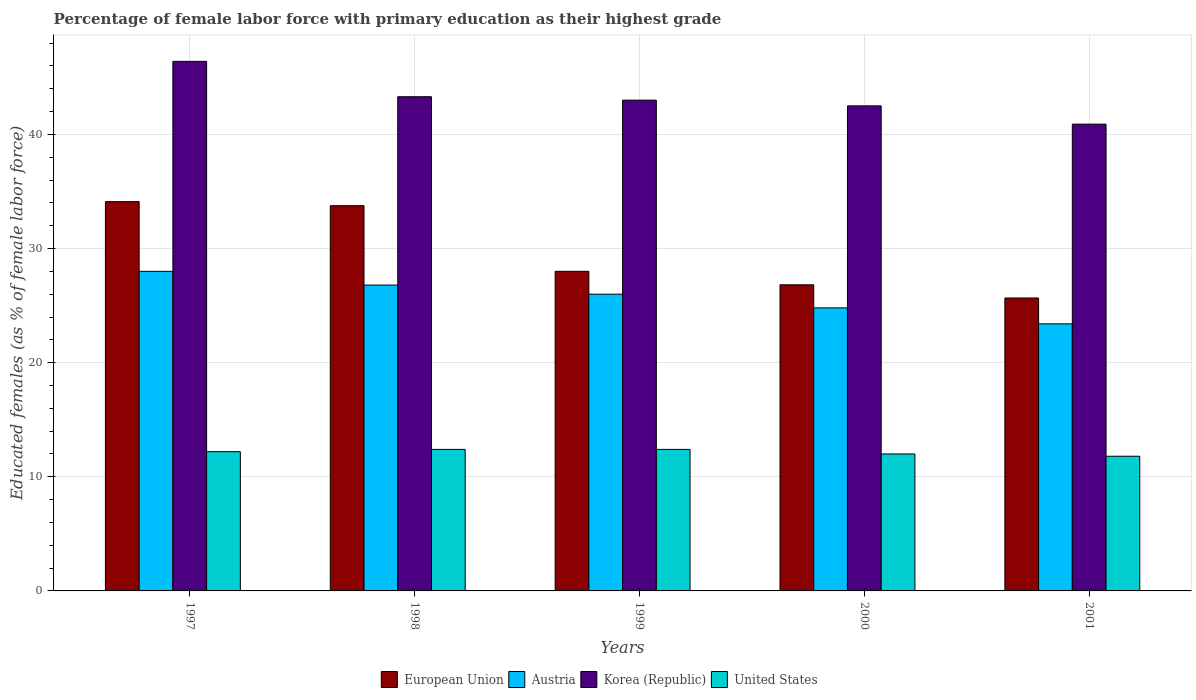How many groups of bars are there?
Provide a short and direct response. 5. Are the number of bars per tick equal to the number of legend labels?
Provide a succinct answer. Yes. How many bars are there on the 2nd tick from the left?
Offer a terse response. 4. How many bars are there on the 5th tick from the right?
Offer a very short reply. 4. What is the label of the 1st group of bars from the left?
Make the answer very short. 1997. What is the percentage of female labor force with primary education in United States in 1997?
Keep it short and to the point. 12.2. Across all years, what is the maximum percentage of female labor force with primary education in Korea (Republic)?
Your answer should be very brief. 46.4. Across all years, what is the minimum percentage of female labor force with primary education in European Union?
Make the answer very short. 25.67. What is the total percentage of female labor force with primary education in European Union in the graph?
Offer a terse response. 148.35. What is the difference between the percentage of female labor force with primary education in European Union in 2000 and that in 2001?
Your answer should be very brief. 1.15. What is the difference between the percentage of female labor force with primary education in Korea (Republic) in 1997 and the percentage of female labor force with primary education in United States in 2001?
Provide a short and direct response. 34.6. What is the average percentage of female labor force with primary education in Austria per year?
Provide a succinct answer. 25.8. In the year 2001, what is the difference between the percentage of female labor force with primary education in Korea (Republic) and percentage of female labor force with primary education in European Union?
Your response must be concise. 15.23. In how many years, is the percentage of female labor force with primary education in United States greater than 10 %?
Offer a very short reply. 5. What is the ratio of the percentage of female labor force with primary education in Austria in 2000 to that in 2001?
Offer a terse response. 1.06. What is the difference between the highest and the second highest percentage of female labor force with primary education in Korea (Republic)?
Offer a terse response. 3.1. What is the difference between the highest and the lowest percentage of female labor force with primary education in Austria?
Provide a short and direct response. 4.6. In how many years, is the percentage of female labor force with primary education in Korea (Republic) greater than the average percentage of female labor force with primary education in Korea (Republic) taken over all years?
Give a very brief answer. 2. Is the sum of the percentage of female labor force with primary education in European Union in 1997 and 2001 greater than the maximum percentage of female labor force with primary education in Austria across all years?
Ensure brevity in your answer.  Yes. What does the 3rd bar from the right in 1997 represents?
Your answer should be compact. Austria. How many bars are there?
Make the answer very short. 20. Are all the bars in the graph horizontal?
Provide a succinct answer. No. How many years are there in the graph?
Ensure brevity in your answer.  5. What is the difference between two consecutive major ticks on the Y-axis?
Your answer should be very brief. 10. How many legend labels are there?
Your answer should be very brief. 4. What is the title of the graph?
Your answer should be compact. Percentage of female labor force with primary education as their highest grade. Does "American Samoa" appear as one of the legend labels in the graph?
Offer a terse response. No. What is the label or title of the Y-axis?
Provide a succinct answer. Educated females (as % of female labor force). What is the Educated females (as % of female labor force) in European Union in 1997?
Offer a terse response. 34.11. What is the Educated females (as % of female labor force) in Korea (Republic) in 1997?
Ensure brevity in your answer.  46.4. What is the Educated females (as % of female labor force) in United States in 1997?
Make the answer very short. 12.2. What is the Educated females (as % of female labor force) of European Union in 1998?
Make the answer very short. 33.75. What is the Educated females (as % of female labor force) of Austria in 1998?
Your answer should be compact. 26.8. What is the Educated females (as % of female labor force) of Korea (Republic) in 1998?
Provide a short and direct response. 43.3. What is the Educated females (as % of female labor force) in United States in 1998?
Provide a succinct answer. 12.4. What is the Educated females (as % of female labor force) of European Union in 1999?
Make the answer very short. 28. What is the Educated females (as % of female labor force) of Austria in 1999?
Give a very brief answer. 26. What is the Educated females (as % of female labor force) of Korea (Republic) in 1999?
Keep it short and to the point. 43. What is the Educated females (as % of female labor force) in United States in 1999?
Give a very brief answer. 12.4. What is the Educated females (as % of female labor force) of European Union in 2000?
Your answer should be compact. 26.82. What is the Educated females (as % of female labor force) in Austria in 2000?
Your answer should be compact. 24.8. What is the Educated females (as % of female labor force) in Korea (Republic) in 2000?
Keep it short and to the point. 42.5. What is the Educated females (as % of female labor force) in United States in 2000?
Your response must be concise. 12. What is the Educated females (as % of female labor force) of European Union in 2001?
Ensure brevity in your answer.  25.67. What is the Educated females (as % of female labor force) in Austria in 2001?
Provide a short and direct response. 23.4. What is the Educated females (as % of female labor force) in Korea (Republic) in 2001?
Keep it short and to the point. 40.9. What is the Educated females (as % of female labor force) in United States in 2001?
Keep it short and to the point. 11.8. Across all years, what is the maximum Educated females (as % of female labor force) of European Union?
Provide a short and direct response. 34.11. Across all years, what is the maximum Educated females (as % of female labor force) of Korea (Republic)?
Keep it short and to the point. 46.4. Across all years, what is the maximum Educated females (as % of female labor force) of United States?
Your response must be concise. 12.4. Across all years, what is the minimum Educated females (as % of female labor force) of European Union?
Make the answer very short. 25.67. Across all years, what is the minimum Educated females (as % of female labor force) of Austria?
Make the answer very short. 23.4. Across all years, what is the minimum Educated females (as % of female labor force) in Korea (Republic)?
Your answer should be compact. 40.9. Across all years, what is the minimum Educated females (as % of female labor force) of United States?
Give a very brief answer. 11.8. What is the total Educated females (as % of female labor force) in European Union in the graph?
Keep it short and to the point. 148.35. What is the total Educated females (as % of female labor force) of Austria in the graph?
Your answer should be compact. 129. What is the total Educated females (as % of female labor force) in Korea (Republic) in the graph?
Offer a terse response. 216.1. What is the total Educated females (as % of female labor force) of United States in the graph?
Offer a very short reply. 60.8. What is the difference between the Educated females (as % of female labor force) of European Union in 1997 and that in 1998?
Make the answer very short. 0.36. What is the difference between the Educated females (as % of female labor force) in Austria in 1997 and that in 1998?
Ensure brevity in your answer.  1.2. What is the difference between the Educated females (as % of female labor force) of Korea (Republic) in 1997 and that in 1998?
Offer a very short reply. 3.1. What is the difference between the Educated females (as % of female labor force) in United States in 1997 and that in 1998?
Your answer should be very brief. -0.2. What is the difference between the Educated females (as % of female labor force) in European Union in 1997 and that in 1999?
Ensure brevity in your answer.  6.11. What is the difference between the Educated females (as % of female labor force) of Austria in 1997 and that in 1999?
Keep it short and to the point. 2. What is the difference between the Educated females (as % of female labor force) of European Union in 1997 and that in 2000?
Your answer should be compact. 7.29. What is the difference between the Educated females (as % of female labor force) in Austria in 1997 and that in 2000?
Provide a short and direct response. 3.2. What is the difference between the Educated females (as % of female labor force) in United States in 1997 and that in 2000?
Your answer should be compact. 0.2. What is the difference between the Educated females (as % of female labor force) in European Union in 1997 and that in 2001?
Your answer should be very brief. 8.44. What is the difference between the Educated females (as % of female labor force) in Austria in 1997 and that in 2001?
Ensure brevity in your answer.  4.6. What is the difference between the Educated females (as % of female labor force) in United States in 1997 and that in 2001?
Offer a very short reply. 0.4. What is the difference between the Educated females (as % of female labor force) of European Union in 1998 and that in 1999?
Your response must be concise. 5.75. What is the difference between the Educated females (as % of female labor force) of Austria in 1998 and that in 1999?
Offer a terse response. 0.8. What is the difference between the Educated females (as % of female labor force) of European Union in 1998 and that in 2000?
Ensure brevity in your answer.  6.93. What is the difference between the Educated females (as % of female labor force) in Korea (Republic) in 1998 and that in 2000?
Your response must be concise. 0.8. What is the difference between the Educated females (as % of female labor force) in European Union in 1998 and that in 2001?
Keep it short and to the point. 8.08. What is the difference between the Educated females (as % of female labor force) of Austria in 1998 and that in 2001?
Your answer should be very brief. 3.4. What is the difference between the Educated females (as % of female labor force) of Korea (Republic) in 1998 and that in 2001?
Your response must be concise. 2.4. What is the difference between the Educated females (as % of female labor force) in European Union in 1999 and that in 2000?
Give a very brief answer. 1.18. What is the difference between the Educated females (as % of female labor force) of Austria in 1999 and that in 2000?
Provide a succinct answer. 1.2. What is the difference between the Educated females (as % of female labor force) in Korea (Republic) in 1999 and that in 2000?
Provide a short and direct response. 0.5. What is the difference between the Educated females (as % of female labor force) in United States in 1999 and that in 2000?
Make the answer very short. 0.4. What is the difference between the Educated females (as % of female labor force) in European Union in 1999 and that in 2001?
Provide a succinct answer. 2.33. What is the difference between the Educated females (as % of female labor force) in Korea (Republic) in 1999 and that in 2001?
Your answer should be very brief. 2.1. What is the difference between the Educated females (as % of female labor force) in United States in 1999 and that in 2001?
Your answer should be compact. 0.6. What is the difference between the Educated females (as % of female labor force) of European Union in 2000 and that in 2001?
Your response must be concise. 1.15. What is the difference between the Educated females (as % of female labor force) of European Union in 1997 and the Educated females (as % of female labor force) of Austria in 1998?
Your response must be concise. 7.31. What is the difference between the Educated females (as % of female labor force) in European Union in 1997 and the Educated females (as % of female labor force) in Korea (Republic) in 1998?
Provide a short and direct response. -9.19. What is the difference between the Educated females (as % of female labor force) of European Union in 1997 and the Educated females (as % of female labor force) of United States in 1998?
Your answer should be very brief. 21.71. What is the difference between the Educated females (as % of female labor force) of Austria in 1997 and the Educated females (as % of female labor force) of Korea (Republic) in 1998?
Provide a short and direct response. -15.3. What is the difference between the Educated females (as % of female labor force) in Korea (Republic) in 1997 and the Educated females (as % of female labor force) in United States in 1998?
Your answer should be compact. 34. What is the difference between the Educated females (as % of female labor force) of European Union in 1997 and the Educated females (as % of female labor force) of Austria in 1999?
Keep it short and to the point. 8.11. What is the difference between the Educated females (as % of female labor force) of European Union in 1997 and the Educated females (as % of female labor force) of Korea (Republic) in 1999?
Keep it short and to the point. -8.89. What is the difference between the Educated females (as % of female labor force) in European Union in 1997 and the Educated females (as % of female labor force) in United States in 1999?
Offer a terse response. 21.71. What is the difference between the Educated females (as % of female labor force) of Austria in 1997 and the Educated females (as % of female labor force) of Korea (Republic) in 1999?
Your response must be concise. -15. What is the difference between the Educated females (as % of female labor force) of Austria in 1997 and the Educated females (as % of female labor force) of United States in 1999?
Your answer should be very brief. 15.6. What is the difference between the Educated females (as % of female labor force) of Korea (Republic) in 1997 and the Educated females (as % of female labor force) of United States in 1999?
Offer a terse response. 34. What is the difference between the Educated females (as % of female labor force) of European Union in 1997 and the Educated females (as % of female labor force) of Austria in 2000?
Offer a very short reply. 9.31. What is the difference between the Educated females (as % of female labor force) in European Union in 1997 and the Educated females (as % of female labor force) in Korea (Republic) in 2000?
Your answer should be very brief. -8.39. What is the difference between the Educated females (as % of female labor force) in European Union in 1997 and the Educated females (as % of female labor force) in United States in 2000?
Keep it short and to the point. 22.11. What is the difference between the Educated females (as % of female labor force) in Austria in 1997 and the Educated females (as % of female labor force) in Korea (Republic) in 2000?
Keep it short and to the point. -14.5. What is the difference between the Educated females (as % of female labor force) in Korea (Republic) in 1997 and the Educated females (as % of female labor force) in United States in 2000?
Make the answer very short. 34.4. What is the difference between the Educated females (as % of female labor force) of European Union in 1997 and the Educated females (as % of female labor force) of Austria in 2001?
Ensure brevity in your answer.  10.71. What is the difference between the Educated females (as % of female labor force) of European Union in 1997 and the Educated females (as % of female labor force) of Korea (Republic) in 2001?
Your answer should be very brief. -6.79. What is the difference between the Educated females (as % of female labor force) of European Union in 1997 and the Educated females (as % of female labor force) of United States in 2001?
Keep it short and to the point. 22.31. What is the difference between the Educated females (as % of female labor force) of Korea (Republic) in 1997 and the Educated females (as % of female labor force) of United States in 2001?
Ensure brevity in your answer.  34.6. What is the difference between the Educated females (as % of female labor force) in European Union in 1998 and the Educated females (as % of female labor force) in Austria in 1999?
Give a very brief answer. 7.75. What is the difference between the Educated females (as % of female labor force) of European Union in 1998 and the Educated females (as % of female labor force) of Korea (Republic) in 1999?
Keep it short and to the point. -9.25. What is the difference between the Educated females (as % of female labor force) in European Union in 1998 and the Educated females (as % of female labor force) in United States in 1999?
Your response must be concise. 21.35. What is the difference between the Educated females (as % of female labor force) of Austria in 1998 and the Educated females (as % of female labor force) of Korea (Republic) in 1999?
Give a very brief answer. -16.2. What is the difference between the Educated females (as % of female labor force) in Korea (Republic) in 1998 and the Educated females (as % of female labor force) in United States in 1999?
Provide a succinct answer. 30.9. What is the difference between the Educated females (as % of female labor force) of European Union in 1998 and the Educated females (as % of female labor force) of Austria in 2000?
Your answer should be very brief. 8.95. What is the difference between the Educated females (as % of female labor force) of European Union in 1998 and the Educated females (as % of female labor force) of Korea (Republic) in 2000?
Your answer should be very brief. -8.75. What is the difference between the Educated females (as % of female labor force) in European Union in 1998 and the Educated females (as % of female labor force) in United States in 2000?
Give a very brief answer. 21.75. What is the difference between the Educated females (as % of female labor force) of Austria in 1998 and the Educated females (as % of female labor force) of Korea (Republic) in 2000?
Give a very brief answer. -15.7. What is the difference between the Educated females (as % of female labor force) of Austria in 1998 and the Educated females (as % of female labor force) of United States in 2000?
Your response must be concise. 14.8. What is the difference between the Educated females (as % of female labor force) in Korea (Republic) in 1998 and the Educated females (as % of female labor force) in United States in 2000?
Provide a succinct answer. 31.3. What is the difference between the Educated females (as % of female labor force) of European Union in 1998 and the Educated females (as % of female labor force) of Austria in 2001?
Offer a terse response. 10.35. What is the difference between the Educated females (as % of female labor force) in European Union in 1998 and the Educated females (as % of female labor force) in Korea (Republic) in 2001?
Provide a succinct answer. -7.15. What is the difference between the Educated females (as % of female labor force) in European Union in 1998 and the Educated females (as % of female labor force) in United States in 2001?
Your response must be concise. 21.95. What is the difference between the Educated females (as % of female labor force) of Austria in 1998 and the Educated females (as % of female labor force) of Korea (Republic) in 2001?
Offer a terse response. -14.1. What is the difference between the Educated females (as % of female labor force) in Austria in 1998 and the Educated females (as % of female labor force) in United States in 2001?
Offer a very short reply. 15. What is the difference between the Educated females (as % of female labor force) of Korea (Republic) in 1998 and the Educated females (as % of female labor force) of United States in 2001?
Keep it short and to the point. 31.5. What is the difference between the Educated females (as % of female labor force) in European Union in 1999 and the Educated females (as % of female labor force) in Austria in 2000?
Offer a very short reply. 3.2. What is the difference between the Educated females (as % of female labor force) of European Union in 1999 and the Educated females (as % of female labor force) of Korea (Republic) in 2000?
Your answer should be very brief. -14.5. What is the difference between the Educated females (as % of female labor force) of European Union in 1999 and the Educated females (as % of female labor force) of United States in 2000?
Offer a terse response. 16. What is the difference between the Educated females (as % of female labor force) in Austria in 1999 and the Educated females (as % of female labor force) in Korea (Republic) in 2000?
Give a very brief answer. -16.5. What is the difference between the Educated females (as % of female labor force) of Austria in 1999 and the Educated females (as % of female labor force) of United States in 2000?
Offer a terse response. 14. What is the difference between the Educated females (as % of female labor force) in European Union in 1999 and the Educated females (as % of female labor force) in Austria in 2001?
Provide a succinct answer. 4.6. What is the difference between the Educated females (as % of female labor force) in European Union in 1999 and the Educated females (as % of female labor force) in Korea (Republic) in 2001?
Make the answer very short. -12.9. What is the difference between the Educated females (as % of female labor force) of European Union in 1999 and the Educated females (as % of female labor force) of United States in 2001?
Your response must be concise. 16.2. What is the difference between the Educated females (as % of female labor force) of Austria in 1999 and the Educated females (as % of female labor force) of Korea (Republic) in 2001?
Your response must be concise. -14.9. What is the difference between the Educated females (as % of female labor force) in Korea (Republic) in 1999 and the Educated females (as % of female labor force) in United States in 2001?
Offer a terse response. 31.2. What is the difference between the Educated females (as % of female labor force) in European Union in 2000 and the Educated females (as % of female labor force) in Austria in 2001?
Give a very brief answer. 3.42. What is the difference between the Educated females (as % of female labor force) of European Union in 2000 and the Educated females (as % of female labor force) of Korea (Republic) in 2001?
Provide a succinct answer. -14.08. What is the difference between the Educated females (as % of female labor force) in European Union in 2000 and the Educated females (as % of female labor force) in United States in 2001?
Keep it short and to the point. 15.02. What is the difference between the Educated females (as % of female labor force) of Austria in 2000 and the Educated females (as % of female labor force) of Korea (Republic) in 2001?
Keep it short and to the point. -16.1. What is the difference between the Educated females (as % of female labor force) of Korea (Republic) in 2000 and the Educated females (as % of female labor force) of United States in 2001?
Provide a short and direct response. 30.7. What is the average Educated females (as % of female labor force) of European Union per year?
Offer a terse response. 29.67. What is the average Educated females (as % of female labor force) in Austria per year?
Offer a very short reply. 25.8. What is the average Educated females (as % of female labor force) in Korea (Republic) per year?
Offer a very short reply. 43.22. What is the average Educated females (as % of female labor force) of United States per year?
Offer a very short reply. 12.16. In the year 1997, what is the difference between the Educated females (as % of female labor force) in European Union and Educated females (as % of female labor force) in Austria?
Make the answer very short. 6.11. In the year 1997, what is the difference between the Educated females (as % of female labor force) of European Union and Educated females (as % of female labor force) of Korea (Republic)?
Keep it short and to the point. -12.29. In the year 1997, what is the difference between the Educated females (as % of female labor force) of European Union and Educated females (as % of female labor force) of United States?
Keep it short and to the point. 21.91. In the year 1997, what is the difference between the Educated females (as % of female labor force) in Austria and Educated females (as % of female labor force) in Korea (Republic)?
Your response must be concise. -18.4. In the year 1997, what is the difference between the Educated females (as % of female labor force) in Austria and Educated females (as % of female labor force) in United States?
Provide a succinct answer. 15.8. In the year 1997, what is the difference between the Educated females (as % of female labor force) of Korea (Republic) and Educated females (as % of female labor force) of United States?
Provide a short and direct response. 34.2. In the year 1998, what is the difference between the Educated females (as % of female labor force) of European Union and Educated females (as % of female labor force) of Austria?
Offer a terse response. 6.95. In the year 1998, what is the difference between the Educated females (as % of female labor force) in European Union and Educated females (as % of female labor force) in Korea (Republic)?
Keep it short and to the point. -9.55. In the year 1998, what is the difference between the Educated females (as % of female labor force) of European Union and Educated females (as % of female labor force) of United States?
Give a very brief answer. 21.35. In the year 1998, what is the difference between the Educated females (as % of female labor force) in Austria and Educated females (as % of female labor force) in Korea (Republic)?
Your answer should be compact. -16.5. In the year 1998, what is the difference between the Educated females (as % of female labor force) of Austria and Educated females (as % of female labor force) of United States?
Provide a succinct answer. 14.4. In the year 1998, what is the difference between the Educated females (as % of female labor force) in Korea (Republic) and Educated females (as % of female labor force) in United States?
Your response must be concise. 30.9. In the year 1999, what is the difference between the Educated females (as % of female labor force) in European Union and Educated females (as % of female labor force) in Austria?
Offer a terse response. 2. In the year 1999, what is the difference between the Educated females (as % of female labor force) in European Union and Educated females (as % of female labor force) in Korea (Republic)?
Give a very brief answer. -15. In the year 1999, what is the difference between the Educated females (as % of female labor force) in European Union and Educated females (as % of female labor force) in United States?
Provide a short and direct response. 15.6. In the year 1999, what is the difference between the Educated females (as % of female labor force) in Austria and Educated females (as % of female labor force) in United States?
Make the answer very short. 13.6. In the year 1999, what is the difference between the Educated females (as % of female labor force) in Korea (Republic) and Educated females (as % of female labor force) in United States?
Keep it short and to the point. 30.6. In the year 2000, what is the difference between the Educated females (as % of female labor force) of European Union and Educated females (as % of female labor force) of Austria?
Provide a short and direct response. 2.02. In the year 2000, what is the difference between the Educated females (as % of female labor force) in European Union and Educated females (as % of female labor force) in Korea (Republic)?
Give a very brief answer. -15.68. In the year 2000, what is the difference between the Educated females (as % of female labor force) in European Union and Educated females (as % of female labor force) in United States?
Offer a terse response. 14.82. In the year 2000, what is the difference between the Educated females (as % of female labor force) in Austria and Educated females (as % of female labor force) in Korea (Republic)?
Provide a succinct answer. -17.7. In the year 2000, what is the difference between the Educated females (as % of female labor force) of Austria and Educated females (as % of female labor force) of United States?
Offer a very short reply. 12.8. In the year 2000, what is the difference between the Educated females (as % of female labor force) in Korea (Republic) and Educated females (as % of female labor force) in United States?
Provide a succinct answer. 30.5. In the year 2001, what is the difference between the Educated females (as % of female labor force) of European Union and Educated females (as % of female labor force) of Austria?
Your response must be concise. 2.27. In the year 2001, what is the difference between the Educated females (as % of female labor force) in European Union and Educated females (as % of female labor force) in Korea (Republic)?
Your answer should be very brief. -15.23. In the year 2001, what is the difference between the Educated females (as % of female labor force) in European Union and Educated females (as % of female labor force) in United States?
Ensure brevity in your answer.  13.87. In the year 2001, what is the difference between the Educated females (as % of female labor force) of Austria and Educated females (as % of female labor force) of Korea (Republic)?
Your answer should be very brief. -17.5. In the year 2001, what is the difference between the Educated females (as % of female labor force) in Korea (Republic) and Educated females (as % of female labor force) in United States?
Your response must be concise. 29.1. What is the ratio of the Educated females (as % of female labor force) in European Union in 1997 to that in 1998?
Your answer should be compact. 1.01. What is the ratio of the Educated females (as % of female labor force) of Austria in 1997 to that in 1998?
Your response must be concise. 1.04. What is the ratio of the Educated females (as % of female labor force) in Korea (Republic) in 1997 to that in 1998?
Make the answer very short. 1.07. What is the ratio of the Educated females (as % of female labor force) in United States in 1997 to that in 1998?
Keep it short and to the point. 0.98. What is the ratio of the Educated females (as % of female labor force) of European Union in 1997 to that in 1999?
Keep it short and to the point. 1.22. What is the ratio of the Educated females (as % of female labor force) of Korea (Republic) in 1997 to that in 1999?
Keep it short and to the point. 1.08. What is the ratio of the Educated females (as % of female labor force) of United States in 1997 to that in 1999?
Ensure brevity in your answer.  0.98. What is the ratio of the Educated females (as % of female labor force) in European Union in 1997 to that in 2000?
Your answer should be compact. 1.27. What is the ratio of the Educated females (as % of female labor force) in Austria in 1997 to that in 2000?
Keep it short and to the point. 1.13. What is the ratio of the Educated females (as % of female labor force) in Korea (Republic) in 1997 to that in 2000?
Your answer should be very brief. 1.09. What is the ratio of the Educated females (as % of female labor force) in United States in 1997 to that in 2000?
Your response must be concise. 1.02. What is the ratio of the Educated females (as % of female labor force) of European Union in 1997 to that in 2001?
Your answer should be very brief. 1.33. What is the ratio of the Educated females (as % of female labor force) in Austria in 1997 to that in 2001?
Give a very brief answer. 1.2. What is the ratio of the Educated females (as % of female labor force) of Korea (Republic) in 1997 to that in 2001?
Ensure brevity in your answer.  1.13. What is the ratio of the Educated females (as % of female labor force) of United States in 1997 to that in 2001?
Keep it short and to the point. 1.03. What is the ratio of the Educated females (as % of female labor force) of European Union in 1998 to that in 1999?
Give a very brief answer. 1.21. What is the ratio of the Educated females (as % of female labor force) in Austria in 1998 to that in 1999?
Give a very brief answer. 1.03. What is the ratio of the Educated females (as % of female labor force) of European Union in 1998 to that in 2000?
Your answer should be compact. 1.26. What is the ratio of the Educated females (as % of female labor force) in Austria in 1998 to that in 2000?
Offer a terse response. 1.08. What is the ratio of the Educated females (as % of female labor force) in Korea (Republic) in 1998 to that in 2000?
Make the answer very short. 1.02. What is the ratio of the Educated females (as % of female labor force) in United States in 1998 to that in 2000?
Offer a terse response. 1.03. What is the ratio of the Educated females (as % of female labor force) in European Union in 1998 to that in 2001?
Ensure brevity in your answer.  1.31. What is the ratio of the Educated females (as % of female labor force) of Austria in 1998 to that in 2001?
Offer a terse response. 1.15. What is the ratio of the Educated females (as % of female labor force) in Korea (Republic) in 1998 to that in 2001?
Keep it short and to the point. 1.06. What is the ratio of the Educated females (as % of female labor force) of United States in 1998 to that in 2001?
Offer a very short reply. 1.05. What is the ratio of the Educated females (as % of female labor force) in European Union in 1999 to that in 2000?
Make the answer very short. 1.04. What is the ratio of the Educated females (as % of female labor force) in Austria in 1999 to that in 2000?
Your response must be concise. 1.05. What is the ratio of the Educated females (as % of female labor force) of Korea (Republic) in 1999 to that in 2000?
Make the answer very short. 1.01. What is the ratio of the Educated females (as % of female labor force) of United States in 1999 to that in 2000?
Offer a terse response. 1.03. What is the ratio of the Educated females (as % of female labor force) of European Union in 1999 to that in 2001?
Ensure brevity in your answer.  1.09. What is the ratio of the Educated females (as % of female labor force) in Korea (Republic) in 1999 to that in 2001?
Your answer should be very brief. 1.05. What is the ratio of the Educated females (as % of female labor force) of United States in 1999 to that in 2001?
Your answer should be very brief. 1.05. What is the ratio of the Educated females (as % of female labor force) of European Union in 2000 to that in 2001?
Your answer should be compact. 1.04. What is the ratio of the Educated females (as % of female labor force) in Austria in 2000 to that in 2001?
Offer a very short reply. 1.06. What is the ratio of the Educated females (as % of female labor force) in Korea (Republic) in 2000 to that in 2001?
Provide a short and direct response. 1.04. What is the ratio of the Educated females (as % of female labor force) in United States in 2000 to that in 2001?
Your answer should be very brief. 1.02. What is the difference between the highest and the second highest Educated females (as % of female labor force) of European Union?
Your answer should be very brief. 0.36. What is the difference between the highest and the lowest Educated females (as % of female labor force) of European Union?
Ensure brevity in your answer.  8.44. What is the difference between the highest and the lowest Educated females (as % of female labor force) in Austria?
Ensure brevity in your answer.  4.6. What is the difference between the highest and the lowest Educated females (as % of female labor force) in Korea (Republic)?
Your answer should be very brief. 5.5. What is the difference between the highest and the lowest Educated females (as % of female labor force) in United States?
Make the answer very short. 0.6. 